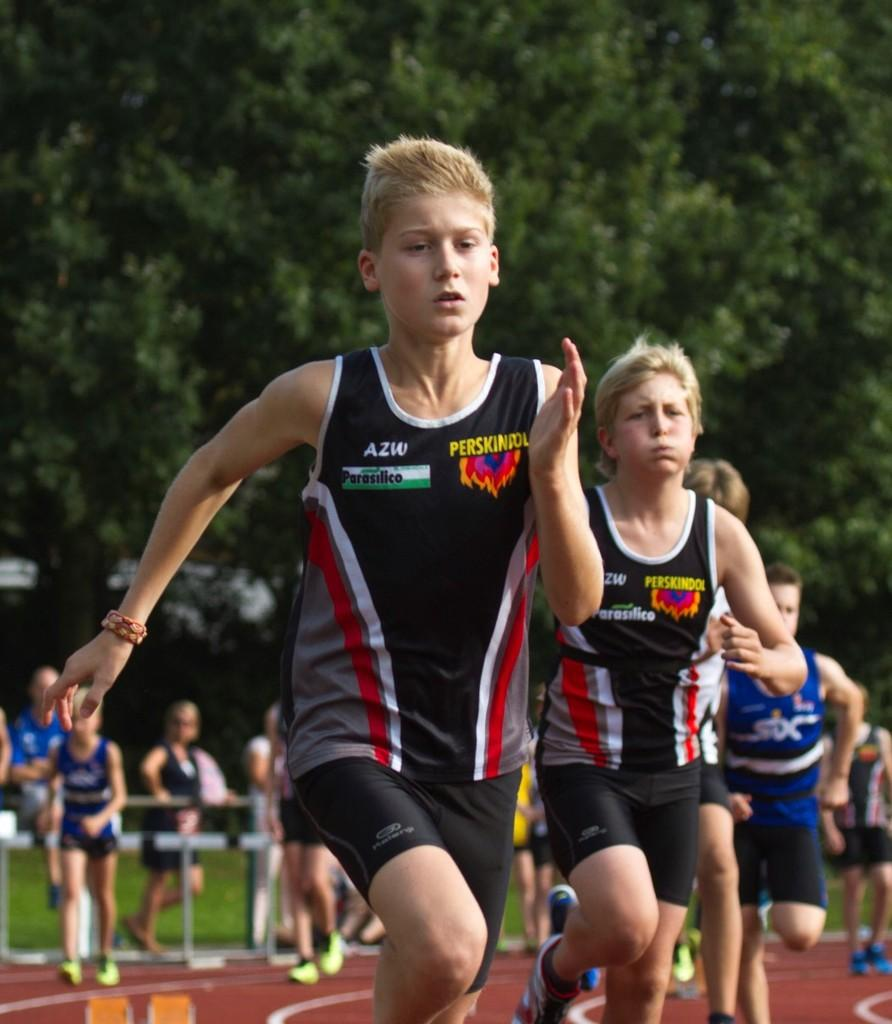<image>
Render a clear and concise summary of the photo. Some young boys are running a race, with the two boy in front wearing black shirts with Perskindol written on them. 